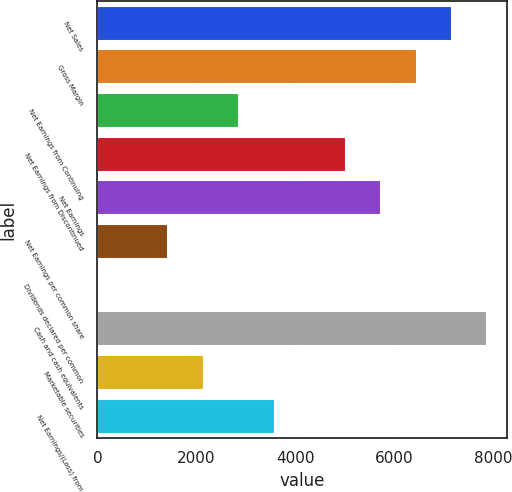<chart> <loc_0><loc_0><loc_500><loc_500><bar_chart><fcel>Net Sales<fcel>Gross Margin<fcel>Net Earnings from Continuing<fcel>Net Earnings from Discontinued<fcel>Net Earnings<fcel>Net Earnings per common share<fcel>Dividends declared per common<fcel>Cash and cash equivalents<fcel>Marketable securities<fcel>Net Earnings/(Loss) from<nl><fcel>7173.01<fcel>6455.74<fcel>2869.39<fcel>5021.2<fcel>5738.47<fcel>1434.85<fcel>0.31<fcel>7890.28<fcel>2152.12<fcel>3586.66<nl></chart> 